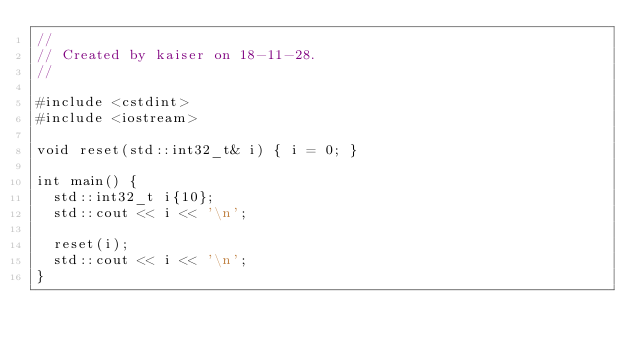<code> <loc_0><loc_0><loc_500><loc_500><_C++_>//
// Created by kaiser on 18-11-28.
//

#include <cstdint>
#include <iostream>

void reset(std::int32_t& i) { i = 0; }

int main() {
  std::int32_t i{10};
  std::cout << i << '\n';

  reset(i);
  std::cout << i << '\n';
}
</code> 